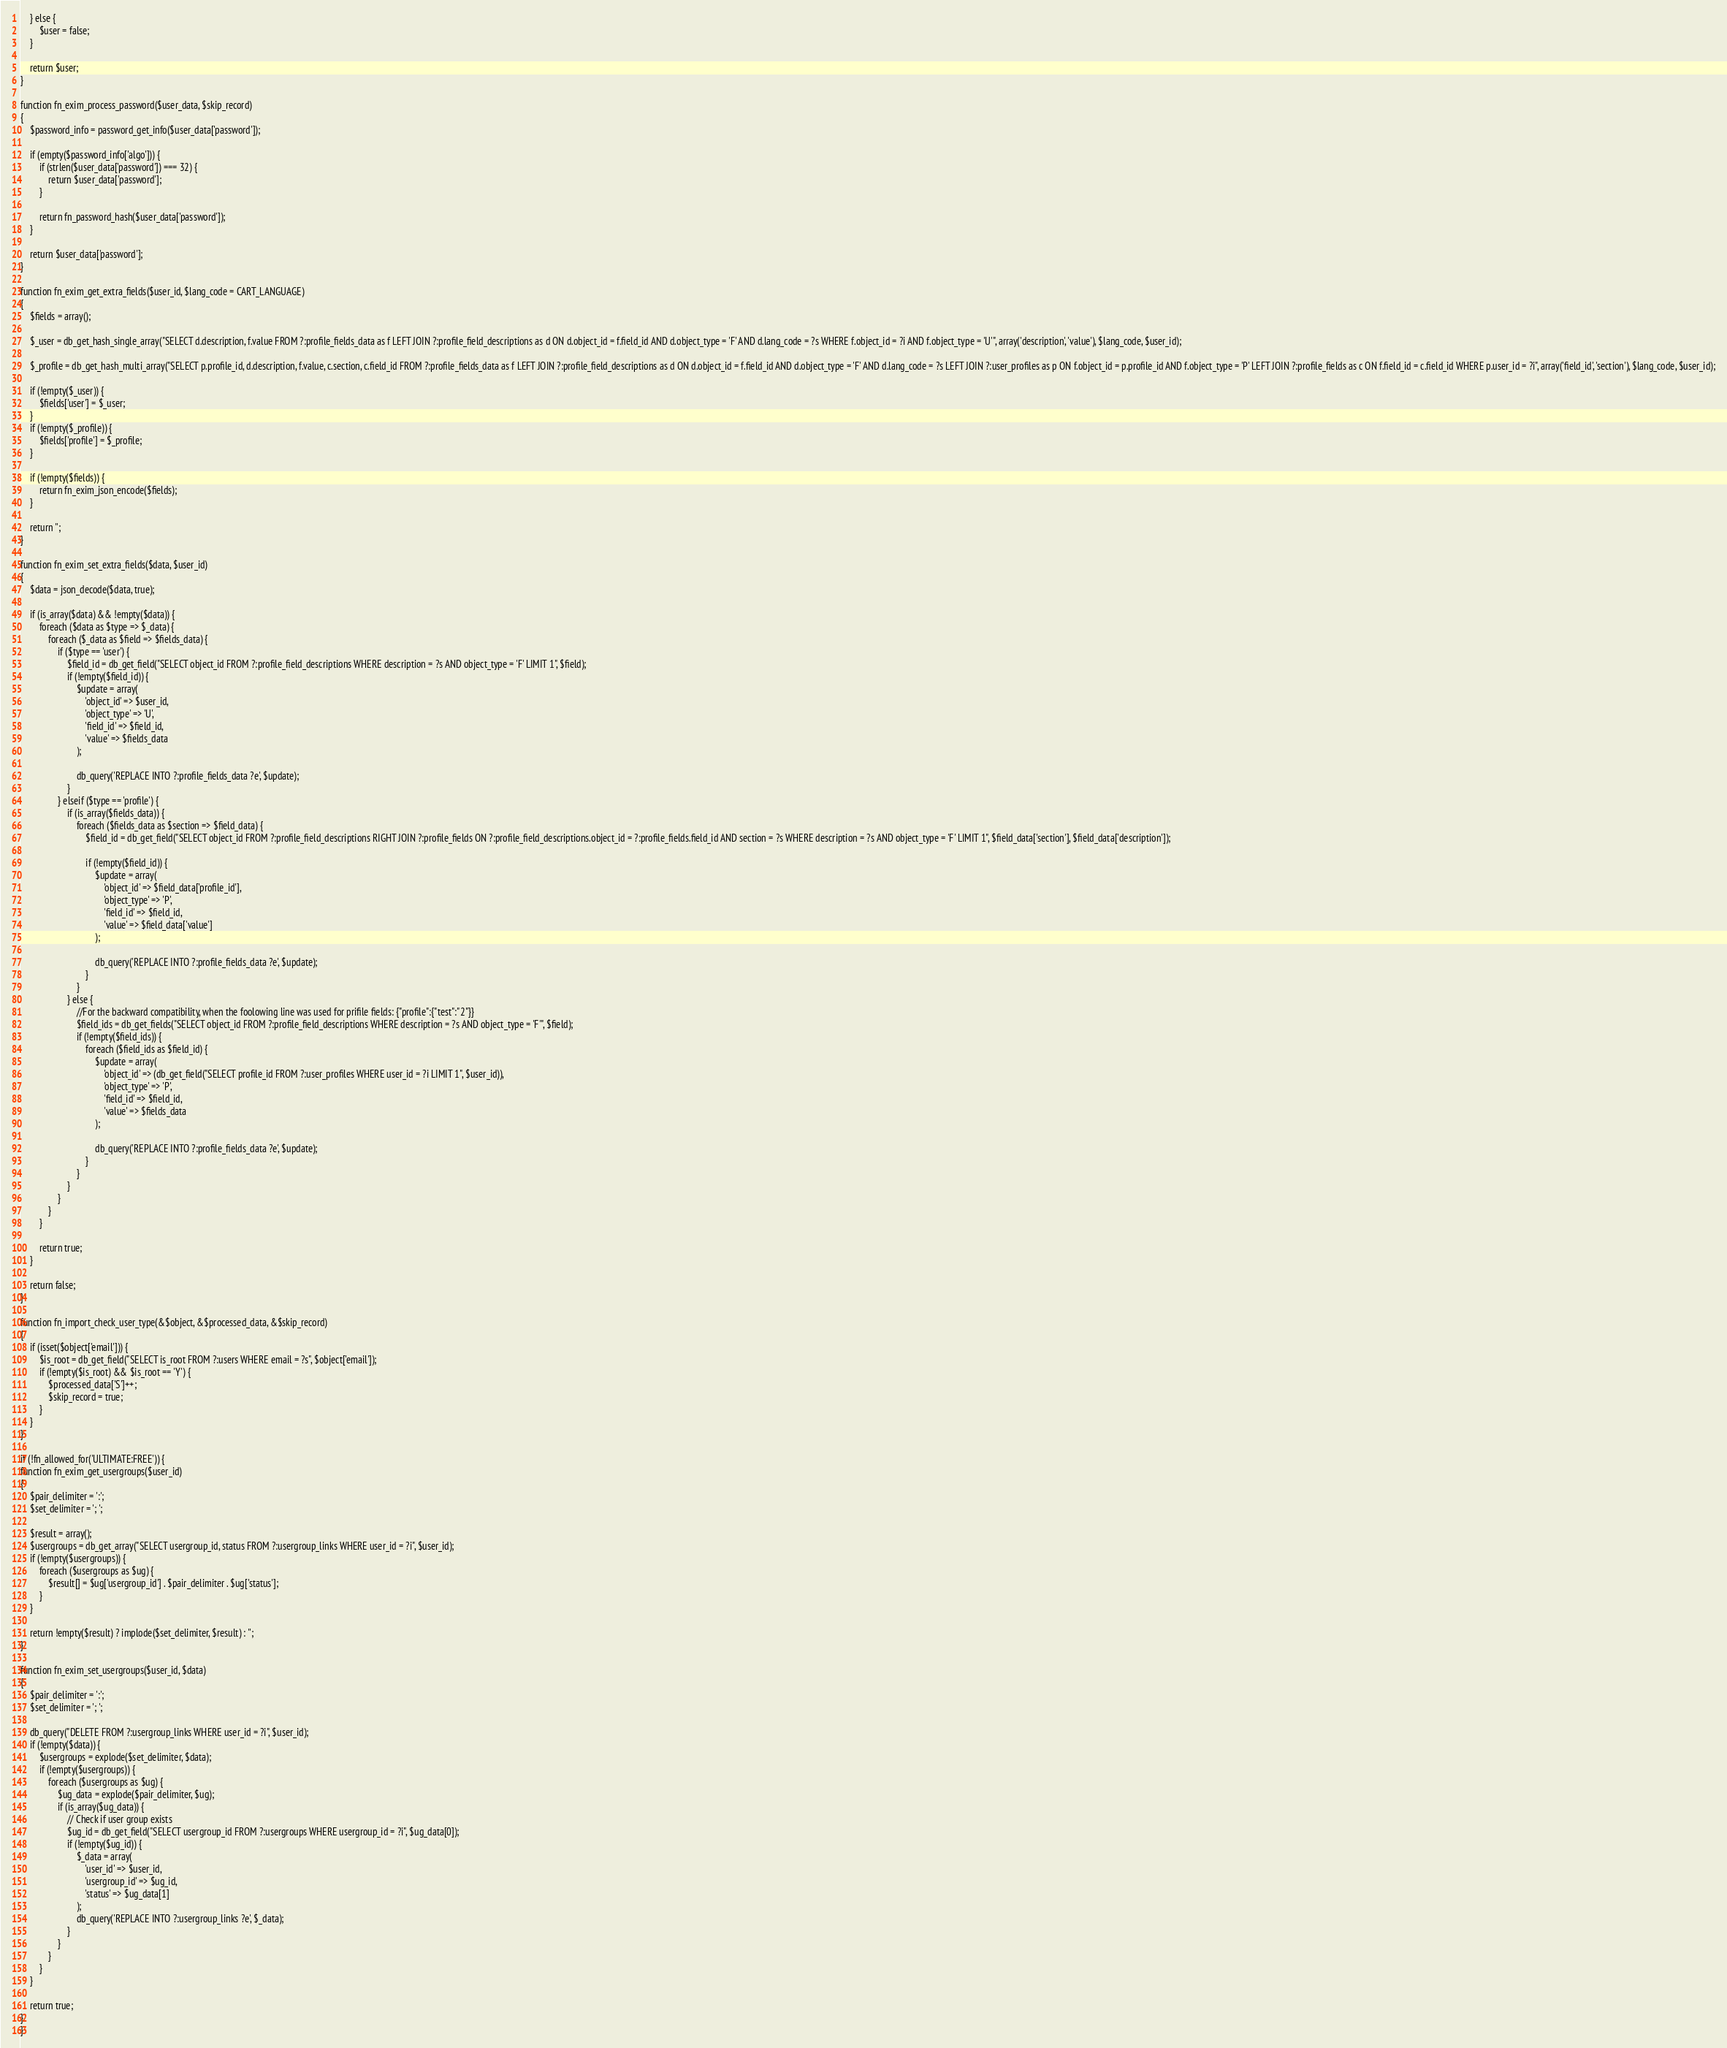<code> <loc_0><loc_0><loc_500><loc_500><_PHP_>    } else {
        $user = false;
    }

    return $user;
}

function fn_exim_process_password($user_data, $skip_record)
{
    $password_info = password_get_info($user_data['password']);

    if (empty($password_info['algo'])) {
        if (strlen($user_data['password']) === 32) {
            return $user_data['password'];
        }

        return fn_password_hash($user_data['password']);
    }

    return $user_data['password'];
}

function fn_exim_get_extra_fields($user_id, $lang_code = CART_LANGUAGE)
{
    $fields = array();

    $_user = db_get_hash_single_array("SELECT d.description, f.value FROM ?:profile_fields_data as f LEFT JOIN ?:profile_field_descriptions as d ON d.object_id = f.field_id AND d.object_type = 'F' AND d.lang_code = ?s WHERE f.object_id = ?i AND f.object_type = 'U'", array('description', 'value'), $lang_code, $user_id);

    $_profile = db_get_hash_multi_array("SELECT p.profile_id, d.description, f.value, c.section, c.field_id FROM ?:profile_fields_data as f LEFT JOIN ?:profile_field_descriptions as d ON d.object_id = f.field_id AND d.object_type = 'F' AND d.lang_code = ?s LEFT JOIN ?:user_profiles as p ON f.object_id = p.profile_id AND f.object_type = 'P' LEFT JOIN ?:profile_fields as c ON f.field_id = c.field_id WHERE p.user_id = ?i", array('field_id', 'section'), $lang_code, $user_id);

    if (!empty($_user)) {
        $fields['user'] = $_user;
    }
    if (!empty($_profile)) {
        $fields['profile'] = $_profile;
    }

    if (!empty($fields)) {
        return fn_exim_json_encode($fields);
    }

    return '';
}

function fn_exim_set_extra_fields($data, $user_id)
{
    $data = json_decode($data, true);

    if (is_array($data) && !empty($data)) {
        foreach ($data as $type => $_data) {
            foreach ($_data as $field => $fields_data) {
                if ($type == 'user') {
                    $field_id = db_get_field("SELECT object_id FROM ?:profile_field_descriptions WHERE description = ?s AND object_type = 'F' LIMIT 1", $field);
                    if (!empty($field_id)) {
                        $update = array(
                            'object_id' => $user_id,
                            'object_type' => 'U',
                            'field_id' => $field_id,
                            'value' => $fields_data
                        );

                        db_query('REPLACE INTO ?:profile_fields_data ?e', $update);
                    }
                } elseif ($type == 'profile') {
                    if (is_array($fields_data)) {
                        foreach ($fields_data as $section => $field_data) {
                            $field_id = db_get_field("SELECT object_id FROM ?:profile_field_descriptions RIGHT JOIN ?:profile_fields ON ?:profile_field_descriptions.object_id = ?:profile_fields.field_id AND section = ?s WHERE description = ?s AND object_type = 'F' LIMIT 1", $field_data['section'], $field_data['description']);

                            if (!empty($field_id)) {
                                $update = array(
                                    'object_id' => $field_data['profile_id'],
                                    'object_type' => 'P',
                                    'field_id' => $field_id,
                                    'value' => $field_data['value']
                                );

                                db_query('REPLACE INTO ?:profile_fields_data ?e', $update);
                            }
                        }
                    } else {
                        //For the backward compatibility, when the foolowing line was used for prifile fields: {"profile":{"test":"2"}}
                        $field_ids = db_get_fields("SELECT object_id FROM ?:profile_field_descriptions WHERE description = ?s AND object_type = 'F'", $field);
                        if (!empty($field_ids)) {
                            foreach ($field_ids as $field_id) {
                                $update = array(
                                    'object_id' => (db_get_field("SELECT profile_id FROM ?:user_profiles WHERE user_id = ?i LIMIT 1", $user_id)),
                                    'object_type' => 'P',
                                    'field_id' => $field_id,
                                    'value' => $fields_data
                                );

                                db_query('REPLACE INTO ?:profile_fields_data ?e', $update);
                            }
                        }
                    }
                }
            }
        }

        return true;
    }

    return false;
}

function fn_import_check_user_type(&$object, &$processed_data, &$skip_record)
{
    if (isset($object['email'])) {
        $is_root = db_get_field("SELECT is_root FROM ?:users WHERE email = ?s", $object['email']);
        if (!empty($is_root) && $is_root == 'Y') {
            $processed_data['S']++;
            $skip_record = true;
        }
    }
}

if (!fn_allowed_for('ULTIMATE:FREE')) {
function fn_exim_get_usergroups($user_id)
{
    $pair_delimiter = ':';
    $set_delimiter = '; ';

    $result = array();
    $usergroups = db_get_array("SELECT usergroup_id, status FROM ?:usergroup_links WHERE user_id = ?i", $user_id);
    if (!empty($usergroups)) {
        foreach ($usergroups as $ug) {
            $result[] = $ug['usergroup_id'] . $pair_delimiter . $ug['status'];
        }
    }

    return !empty($result) ? implode($set_delimiter, $result) : '';
}

function fn_exim_set_usergroups($user_id, $data)
{
    $pair_delimiter = ':';
    $set_delimiter = '; ';

    db_query("DELETE FROM ?:usergroup_links WHERE user_id = ?i", $user_id);
    if (!empty($data)) {
        $usergroups = explode($set_delimiter, $data);
        if (!empty($usergroups)) {
            foreach ($usergroups as $ug) {
                $ug_data = explode($pair_delimiter, $ug);
                if (is_array($ug_data)) {
                    // Check if user group exists
                    $ug_id = db_get_field("SELECT usergroup_id FROM ?:usergroups WHERE usergroup_id = ?i", $ug_data[0]);
                    if (!empty($ug_id)) {
                        $_data = array(
                            'user_id' => $user_id,
                            'usergroup_id' => $ug_id,
                            'status' => $ug_data[1]
                        );
                        db_query('REPLACE INTO ?:usergroup_links ?e', $_data);
                    }
                }
            }
        }
    }

    return true;
}
}
</code> 